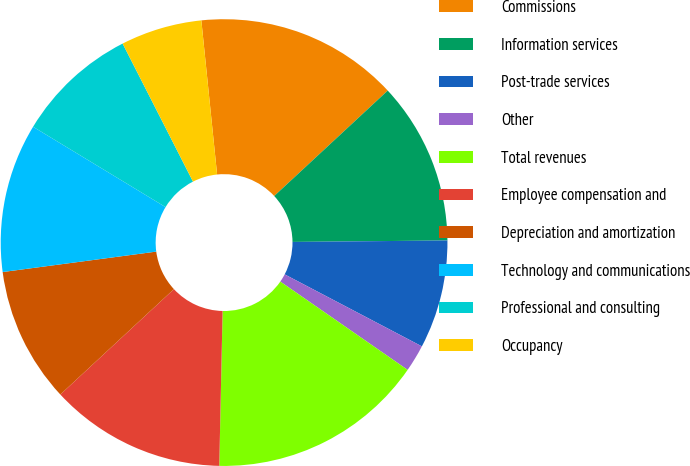<chart> <loc_0><loc_0><loc_500><loc_500><pie_chart><fcel>Commissions<fcel>Information services<fcel>Post-trade services<fcel>Other<fcel>Total revenues<fcel>Employee compensation and<fcel>Depreciation and amortization<fcel>Technology and communications<fcel>Professional and consulting<fcel>Occupancy<nl><fcel>14.71%<fcel>11.76%<fcel>7.84%<fcel>1.96%<fcel>15.69%<fcel>12.75%<fcel>9.8%<fcel>10.78%<fcel>8.82%<fcel>5.88%<nl></chart> 